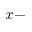<formula> <loc_0><loc_0><loc_500><loc_500>x -</formula> 